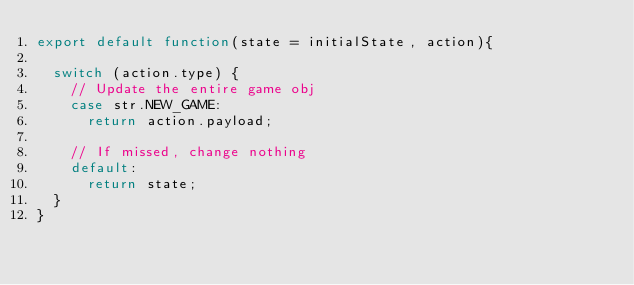Convert code to text. <code><loc_0><loc_0><loc_500><loc_500><_JavaScript_>export default function(state = initialState, action){

  switch (action.type) {
    // Update the entire game obj
    case str.NEW_GAME:
      return action.payload;

    // If missed, change nothing
    default:
      return state;
  }
}
</code> 